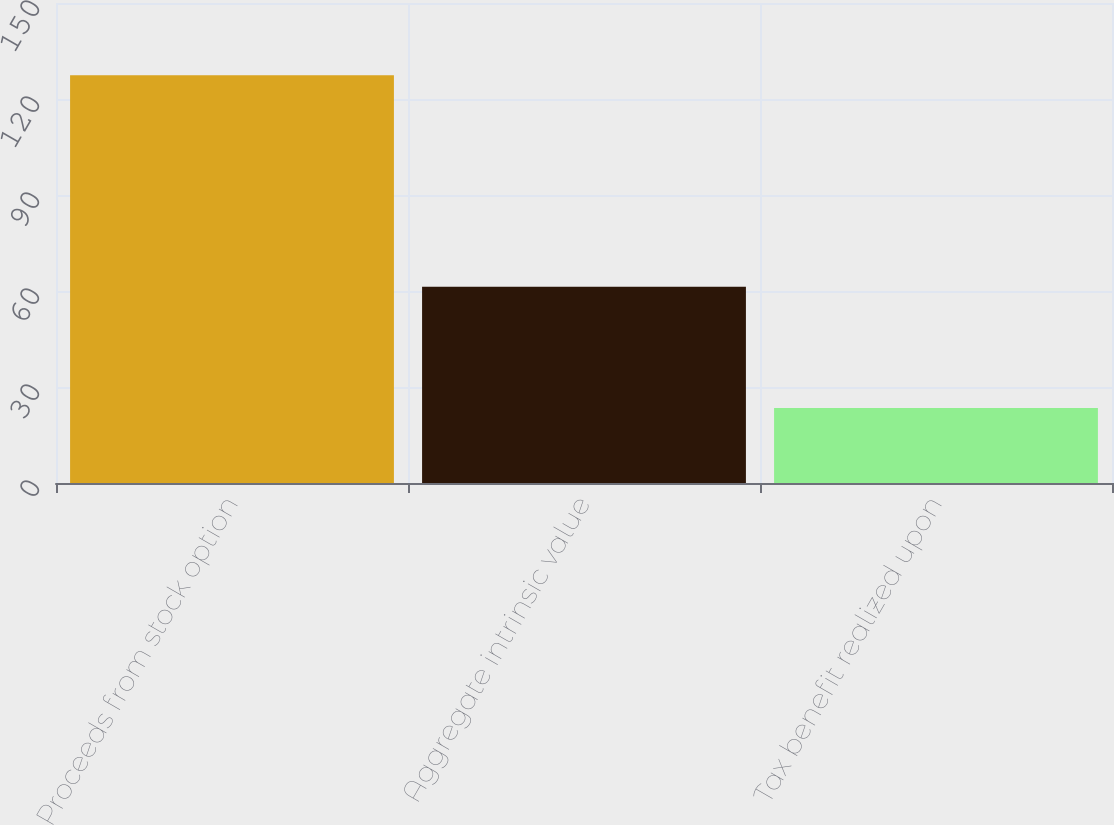Convert chart. <chart><loc_0><loc_0><loc_500><loc_500><bar_chart><fcel>Proceeds from stock option<fcel>Aggregate intrinsic value<fcel>Tax benefit realized upon<nl><fcel>127.4<fcel>61.3<fcel>23.4<nl></chart> 